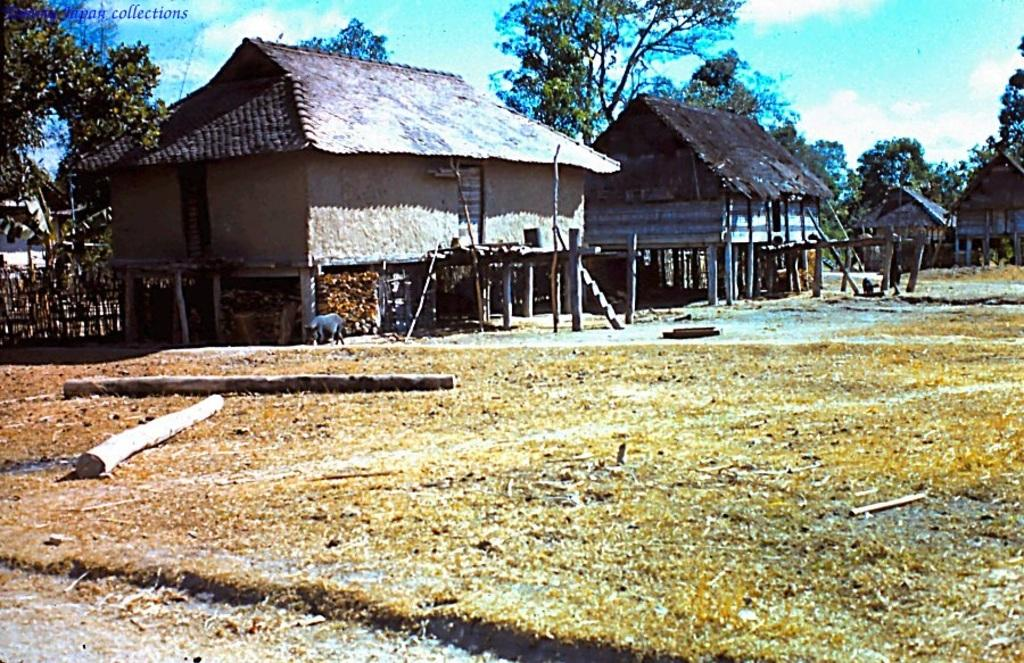What is located in the foreground of the image? There is a land in the foreground of the image. What structures can be seen behind the land? There are houses behind the land. What type of natural elements are visible in the background of the image? There are trees in the background of the image. What type of rhythm can be heard coming from the governor's toes in the image? There is no governor or toes present in the image, so it's not possible to determine any rhythm. 